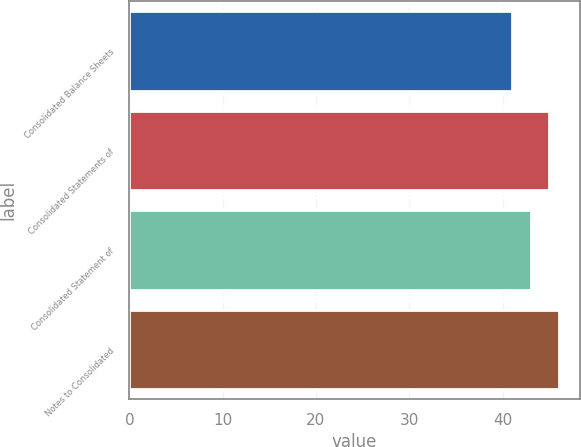<chart> <loc_0><loc_0><loc_500><loc_500><bar_chart><fcel>Consolidated Balance Sheets<fcel>Consolidated Statements of<fcel>Consolidated Statement of<fcel>Notes to Consolidated<nl><fcel>41<fcel>45<fcel>43<fcel>46<nl></chart> 